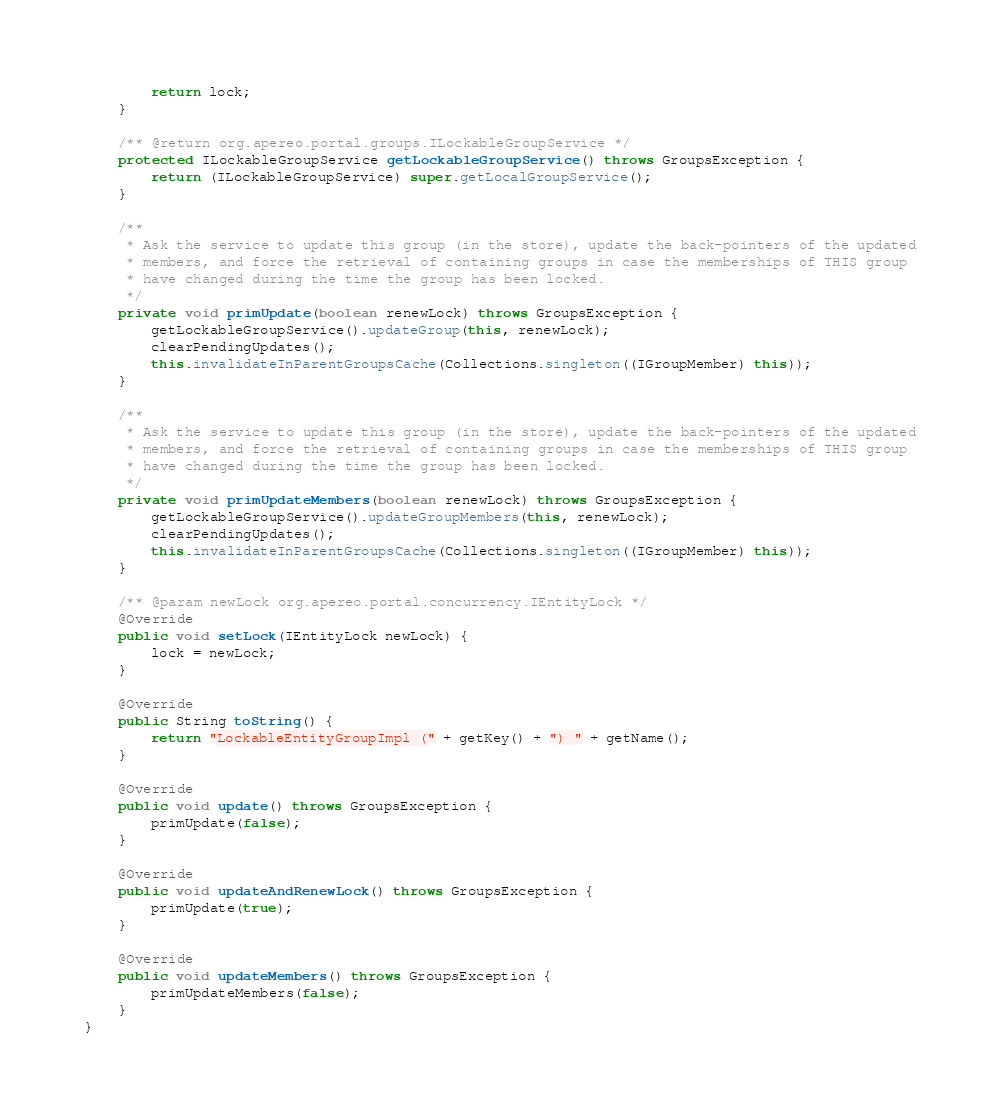<code> <loc_0><loc_0><loc_500><loc_500><_Java_>        return lock;
    }

    /** @return org.apereo.portal.groups.ILockableGroupService */
    protected ILockableGroupService getLockableGroupService() throws GroupsException {
        return (ILockableGroupService) super.getLocalGroupService();
    }

    /**
     * Ask the service to update this group (in the store), update the back-pointers of the updated
     * members, and force the retrieval of containing groups in case the memberships of THIS group
     * have changed during the time the group has been locked.
     */
    private void primUpdate(boolean renewLock) throws GroupsException {
        getLockableGroupService().updateGroup(this, renewLock);
        clearPendingUpdates();
        this.invalidateInParentGroupsCache(Collections.singleton((IGroupMember) this));
    }

    /**
     * Ask the service to update this group (in the store), update the back-pointers of the updated
     * members, and force the retrieval of containing groups in case the memberships of THIS group
     * have changed during the time the group has been locked.
     */
    private void primUpdateMembers(boolean renewLock) throws GroupsException {
        getLockableGroupService().updateGroupMembers(this, renewLock);
        clearPendingUpdates();
        this.invalidateInParentGroupsCache(Collections.singleton((IGroupMember) this));
    }

    /** @param newLock org.apereo.portal.concurrency.IEntityLock */
    @Override
    public void setLock(IEntityLock newLock) {
        lock = newLock;
    }

    @Override
    public String toString() {
        return "LockableEntityGroupImpl (" + getKey() + ") " + getName();
    }

    @Override
    public void update() throws GroupsException {
        primUpdate(false);
    }

    @Override
    public void updateAndRenewLock() throws GroupsException {
        primUpdate(true);
    }

    @Override
    public void updateMembers() throws GroupsException {
        primUpdateMembers(false);
    }
}
</code> 